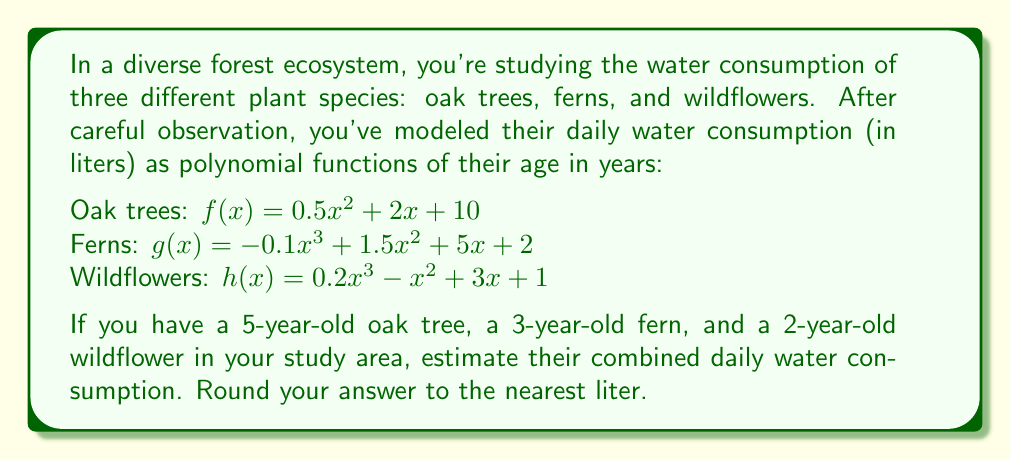Teach me how to tackle this problem. To solve this problem, we need to calculate the water consumption for each plant species using their respective polynomial functions and the given ages. Then, we'll sum up the results.

1. For the oak tree (5 years old):
   $f(5) = 0.5(5^2) + 2(5) + 10$
   $= 0.5(25) + 10 + 10$
   $= 12.5 + 20$
   $= 32.5$ liters

2. For the fern (3 years old):
   $g(3) = -0.1(3^3) + 1.5(3^2) + 5(3) + 2$
   $= -0.1(27) + 1.5(9) + 15 + 2$
   $= -2.7 + 13.5 + 17$
   $= 27.8$ liters

3. For the wildflower (2 years old):
   $h(2) = 0.2(2^3) - (2^2) + 3(2) + 1$
   $= 0.2(8) - 4 + 6 + 1$
   $= 1.6 - 4 + 7$
   $= 4.6$ liters

Now, we sum up the water consumption of all three plants:
$32.5 + 27.8 + 4.6 = 64.9$ liters

Rounding to the nearest liter, we get 65 liters.
Answer: 65 liters 